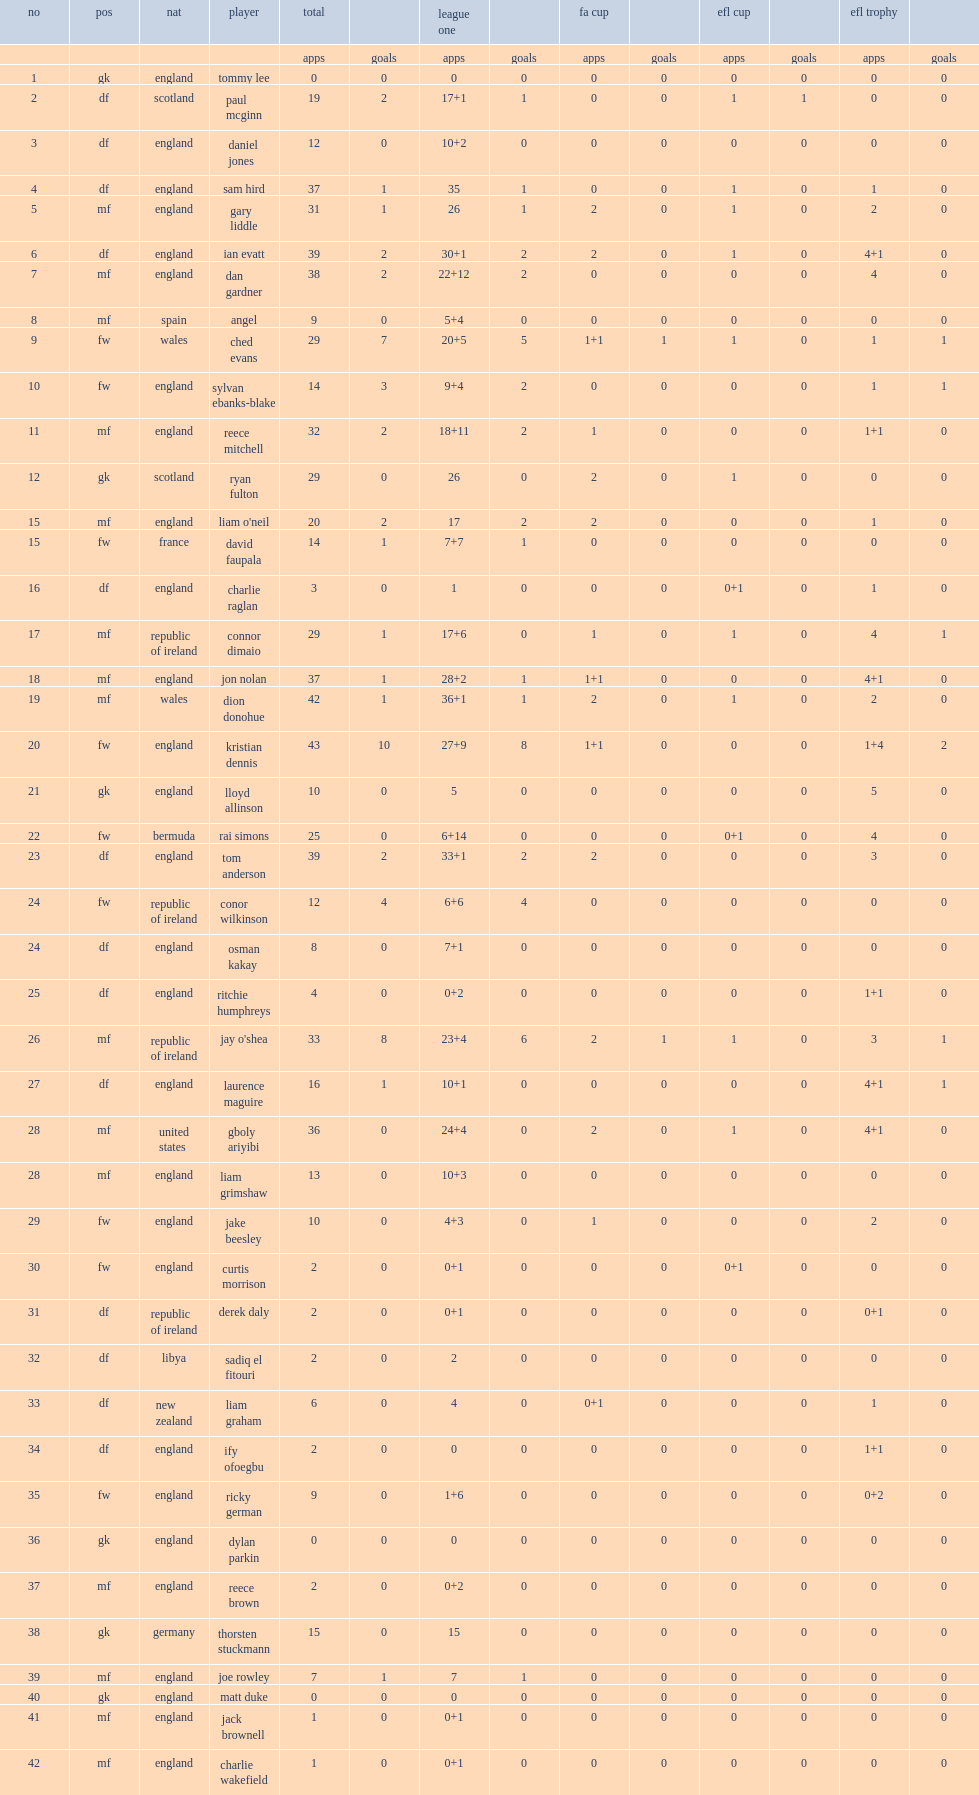Along with league one, what cups did the chesterfield club participated in? Fa cup efl cup efl trophy. Could you parse the entire table? {'header': ['no', 'pos', 'nat', 'player', 'total', '', 'league one', '', 'fa cup', '', 'efl cup', '', 'efl trophy', ''], 'rows': [['', '', '', '', 'apps', 'goals', 'apps', 'goals', 'apps', 'goals', 'apps', 'goals', 'apps', 'goals'], ['1', 'gk', 'england', 'tommy lee', '0', '0', '0', '0', '0', '0', '0', '0', '0', '0'], ['2', 'df', 'scotland', 'paul mcginn', '19', '2', '17+1', '1', '0', '0', '1', '1', '0', '0'], ['3', 'df', 'england', 'daniel jones', '12', '0', '10+2', '0', '0', '0', '0', '0', '0', '0'], ['4', 'df', 'england', 'sam hird', '37', '1', '35', '1', '0', '0', '1', '0', '1', '0'], ['5', 'mf', 'england', 'gary liddle', '31', '1', '26', '1', '2', '0', '1', '0', '2', '0'], ['6', 'df', 'england', 'ian evatt', '39', '2', '30+1', '2', '2', '0', '1', '0', '4+1', '0'], ['7', 'mf', 'england', 'dan gardner', '38', '2', '22+12', '2', '0', '0', '0', '0', '4', '0'], ['8', 'mf', 'spain', 'angel', '9', '0', '5+4', '0', '0', '0', '0', '0', '0', '0'], ['9', 'fw', 'wales', 'ched evans', '29', '7', '20+5', '5', '1+1', '1', '1', '0', '1', '1'], ['10', 'fw', 'england', 'sylvan ebanks-blake', '14', '3', '9+4', '2', '0', '0', '0', '0', '1', '1'], ['11', 'mf', 'england', 'reece mitchell', '32', '2', '18+11', '2', '1', '0', '0', '0', '1+1', '0'], ['12', 'gk', 'scotland', 'ryan fulton', '29', '0', '26', '0', '2', '0', '1', '0', '0', '0'], ['15', 'mf', 'england', "liam o'neil", '20', '2', '17', '2', '2', '0', '0', '0', '1', '0'], ['15', 'fw', 'france', 'david faupala', '14', '1', '7+7', '1', '0', '0', '0', '0', '0', '0'], ['16', 'df', 'england', 'charlie raglan', '3', '0', '1', '0', '0', '0', '0+1', '0', '1', '0'], ['17', 'mf', 'republic of ireland', 'connor dimaio', '29', '1', '17+6', '0', '1', '0', '1', '0', '4', '1'], ['18', 'mf', 'england', 'jon nolan', '37', '1', '28+2', '1', '1+1', '0', '0', '0', '4+1', '0'], ['19', 'mf', 'wales', 'dion donohue', '42', '1', '36+1', '1', '2', '0', '1', '0', '2', '0'], ['20', 'fw', 'england', 'kristian dennis', '43', '10', '27+9', '8', '1+1', '0', '0', '0', '1+4', '2'], ['21', 'gk', 'england', 'lloyd allinson', '10', '0', '5', '0', '0', '0', '0', '0', '5', '0'], ['22', 'fw', 'bermuda', 'rai simons', '25', '0', '6+14', '0', '0', '0', '0+1', '0', '4', '0'], ['23', 'df', 'england', 'tom anderson', '39', '2', '33+1', '2', '2', '0', '0', '0', '3', '0'], ['24', 'fw', 'republic of ireland', 'conor wilkinson', '12', '4', '6+6', '4', '0', '0', '0', '0', '0', '0'], ['24', 'df', 'england', 'osman kakay', '8', '0', '7+1', '0', '0', '0', '0', '0', '0', '0'], ['25', 'df', 'england', 'ritchie humphreys', '4', '0', '0+2', '0', '0', '0', '0', '0', '1+1', '0'], ['26', 'mf', 'republic of ireland', "jay o'shea", '33', '8', '23+4', '6', '2', '1', '1', '0', '3', '1'], ['27', 'df', 'england', 'laurence maguire', '16', '1', '10+1', '0', '0', '0', '0', '0', '4+1', '1'], ['28', 'mf', 'united states', 'gboly ariyibi', '36', '0', '24+4', '0', '2', '0', '1', '0', '4+1', '0'], ['28', 'mf', 'england', 'liam grimshaw', '13', '0', '10+3', '0', '0', '0', '0', '0', '0', '0'], ['29', 'fw', 'england', 'jake beesley', '10', '0', '4+3', '0', '1', '0', '0', '0', '2', '0'], ['30', 'fw', 'england', 'curtis morrison', '2', '0', '0+1', '0', '0', '0', '0+1', '0', '0', '0'], ['31', 'df', 'republic of ireland', 'derek daly', '2', '0', '0+1', '0', '0', '0', '0', '0', '0+1', '0'], ['32', 'df', 'libya', 'sadiq el fitouri', '2', '0', '2', '0', '0', '0', '0', '0', '0', '0'], ['33', 'df', 'new zealand', 'liam graham', '6', '0', '4', '0', '0+1', '0', '0', '0', '1', '0'], ['34', 'df', 'england', 'ify ofoegbu', '2', '0', '0', '0', '0', '0', '0', '0', '1+1', '0'], ['35', 'fw', 'england', 'ricky german', '9', '0', '1+6', '0', '0', '0', '0', '0', '0+2', '0'], ['36', 'gk', 'england', 'dylan parkin', '0', '0', '0', '0', '0', '0', '0', '0', '0', '0'], ['37', 'mf', 'england', 'reece brown', '2', '0', '0+2', '0', '0', '0', '0', '0', '0', '0'], ['38', 'gk', 'germany', 'thorsten stuckmann', '15', '0', '15', '0', '0', '0', '0', '0', '0', '0'], ['39', 'mf', 'england', 'joe rowley', '7', '1', '7', '1', '0', '0', '0', '0', '0', '0'], ['40', 'gk', 'england', 'matt duke', '0', '0', '0', '0', '0', '0', '0', '0', '0', '0'], ['41', 'mf', 'england', 'jack brownell', '1', '0', '0+1', '0', '0', '0', '0', '0', '0', '0'], ['42', 'mf', 'england', 'charlie wakefield', '1', '0', '0+1', '0', '0', '0', '0', '0', '0', '0']]} 